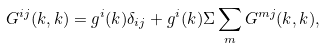<formula> <loc_0><loc_0><loc_500><loc_500>G ^ { i j } ( { k } , { k } ) = g ^ { i } ( { k } ) \delta _ { i j } + g ^ { i } ( { k } ) \Sigma \sum _ { m } G ^ { m j } ( { k } , { k } ) ,</formula> 